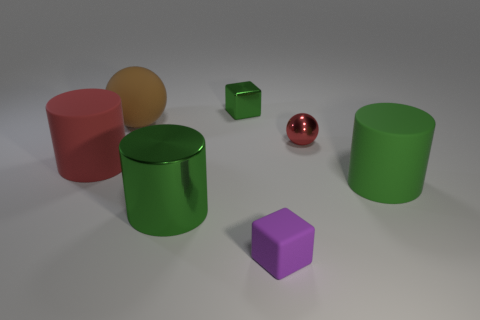Are the red object that is on the right side of the metallic cylinder and the green block made of the same material? While the red spherical object and the green cube may appear similar in a few aspects such as their shapes being simple geometrical figures, differences in their surfaces suggest they might not be made of the exact same material. The red sphere has a glossy finish reflective of a smooth, possibly metallic surface, while the green cube exhibits a matte surface, potentially indicative of a plastic material. Without additional context or information, it can't be confirmed with certainty, but the visual cues point to a difference in material. 